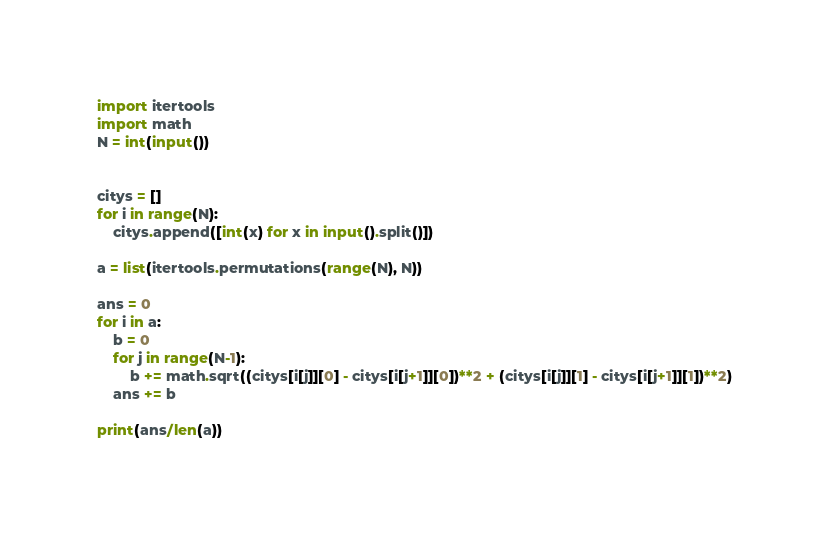Convert code to text. <code><loc_0><loc_0><loc_500><loc_500><_Python_>import itertools
import math
N = int(input())


citys = []
for i in range(N):
    citys.append([int(x) for x in input().split()])

a = list(itertools.permutations(range(N), N))

ans = 0
for i in a:
    b = 0
    for j in range(N-1):
        b += math.sqrt((citys[i[j]][0] - citys[i[j+1]][0])**2 + (citys[i[j]][1] - citys[i[j+1]][1])**2)
    ans += b

print(ans/len(a))
</code> 